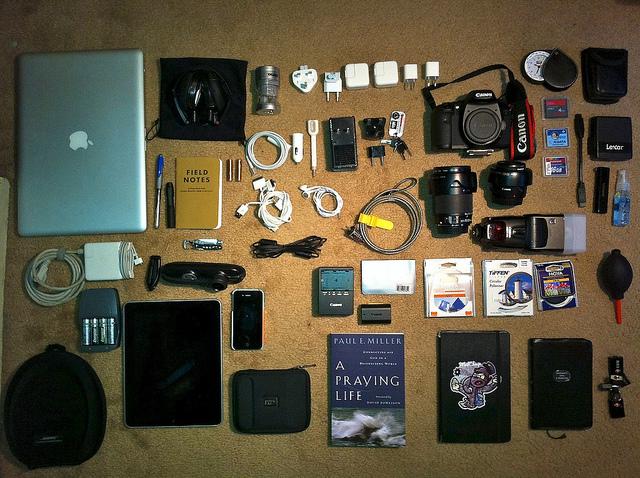Are any electronics shown in this picture?
Write a very short answer. Yes. What is the title of the book seen?
Short answer required. A praying life. What is the red and black circle object on the left?
Answer briefly. Nothing. What is the brand of camera at the top?
Short answer required. Canon. What is the title of the purple book?
Keep it brief. A praying life. Are all the gadgets remotes?
Concise answer only. No. 